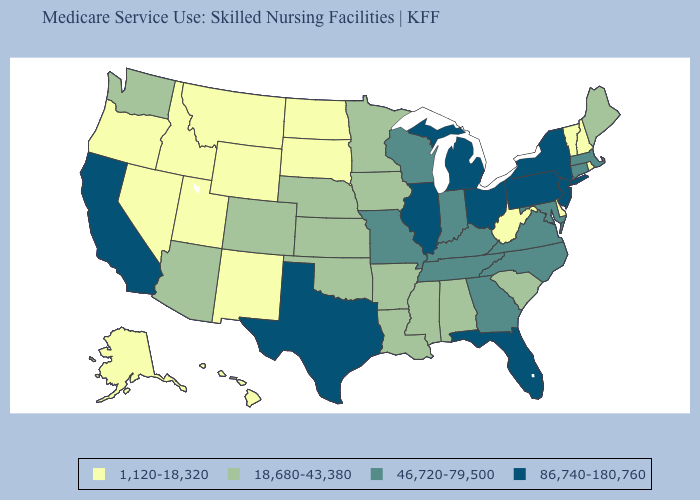What is the lowest value in the USA?
Keep it brief. 1,120-18,320. Name the states that have a value in the range 86,740-180,760?
Give a very brief answer. California, Florida, Illinois, Michigan, New Jersey, New York, Ohio, Pennsylvania, Texas. Name the states that have a value in the range 18,680-43,380?
Concise answer only. Alabama, Arizona, Arkansas, Colorado, Iowa, Kansas, Louisiana, Maine, Minnesota, Mississippi, Nebraska, Oklahoma, South Carolina, Washington. Which states hav the highest value in the South?
Answer briefly. Florida, Texas. Name the states that have a value in the range 46,720-79,500?
Give a very brief answer. Connecticut, Georgia, Indiana, Kentucky, Maryland, Massachusetts, Missouri, North Carolina, Tennessee, Virginia, Wisconsin. Does the first symbol in the legend represent the smallest category?
Write a very short answer. Yes. Which states have the lowest value in the USA?
Keep it brief. Alaska, Delaware, Hawaii, Idaho, Montana, Nevada, New Hampshire, New Mexico, North Dakota, Oregon, Rhode Island, South Dakota, Utah, Vermont, West Virginia, Wyoming. Does Iowa have the same value as Georgia?
Write a very short answer. No. Does Connecticut have the lowest value in the Northeast?
Answer briefly. No. Does California have the highest value in the West?
Be succinct. Yes. How many symbols are there in the legend?
Be succinct. 4. Is the legend a continuous bar?
Keep it brief. No. Does Oklahoma have the lowest value in the USA?
Keep it brief. No. Does Kentucky have the same value as Maryland?
Answer briefly. Yes. Among the states that border Kansas , which have the lowest value?
Write a very short answer. Colorado, Nebraska, Oklahoma. 